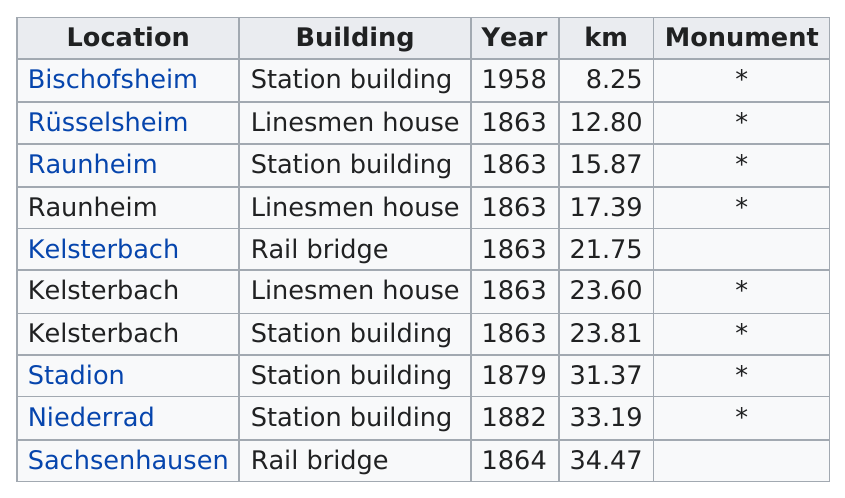Specify some key components in this picture. The location with the least kilometers is Bischofsheim. The total number of buildings that are monuments is 8. There are six buildings that were constructed in the year 1863. Sachsenhausen has the most kilometers. Kelsterbach has more total kilometers than Stadion. 